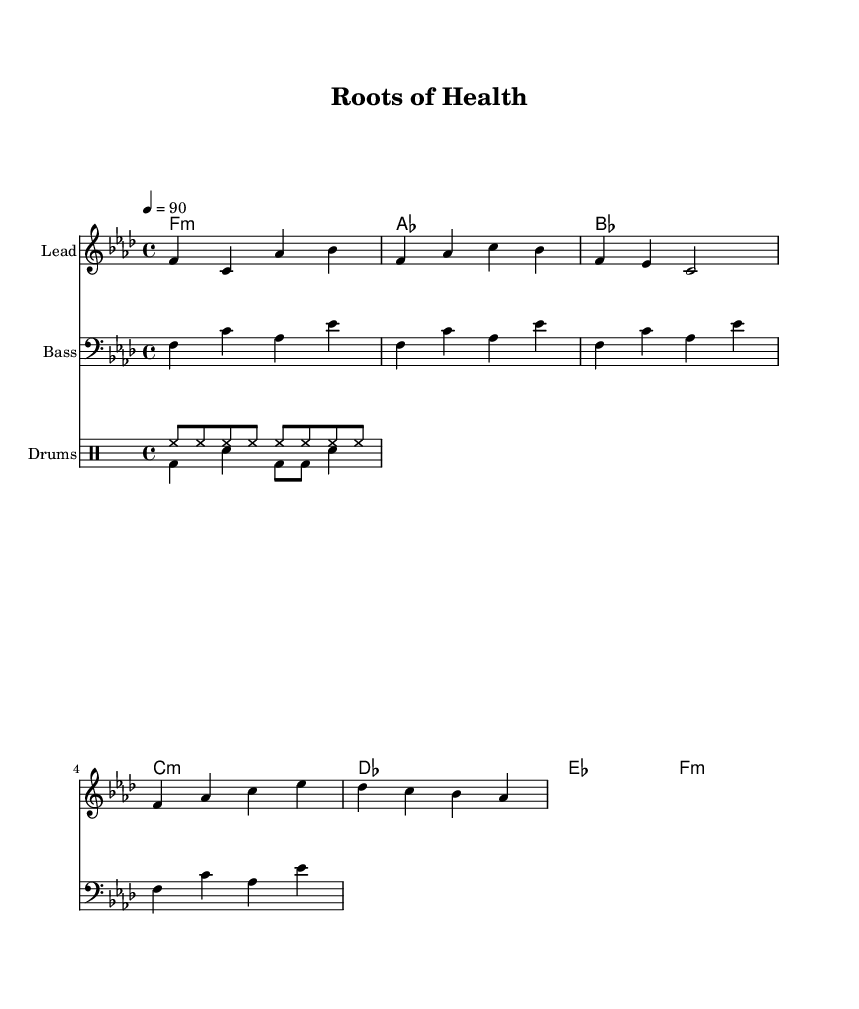What is the key signature of this music? The key signature is indicated at the beginning of the staff and shows a flat sign, which means it is in F minor.
Answer: F minor What is the time signature of this music? The time signature is displayed as "4/4" at the beginning, meaning there are four beats in a measure and the quarter note gets one beat.
Answer: 4/4 What is the tempo marking of this music? The tempo marking is noted as "4 = 90," indicating that the quarter note should be played at 90 beats per minute.
Answer: 90 How many measures are in the melody section? By counting the measures in the melody part, there are a total of 5 measures in the melody section.
Answer: 5 What type of music is this? The title and thematic content, including a focus on food systems and health, indicate that it is a Hip Hop song.
Answer: Hip Hop What instruments are used in this piece? The score includes parts for Lead (melody), Bass, and Drums, indicating a combination of instrumental roles.
Answer: Lead, Bass, Drums What is the overall theme of the lyrics? The lyrics reference the connection between food and health, emphasizing organic produce and community empowerment.
Answer: Food and health 